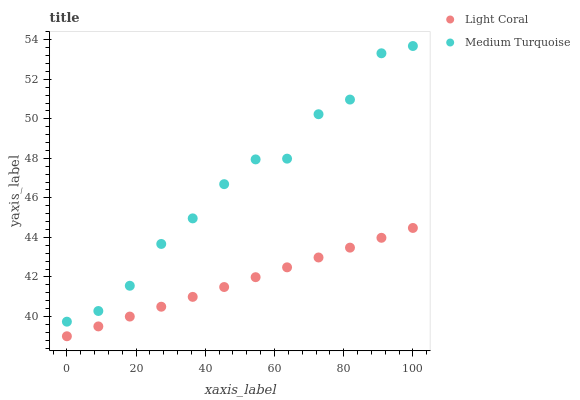Does Light Coral have the minimum area under the curve?
Answer yes or no. Yes. Does Medium Turquoise have the maximum area under the curve?
Answer yes or no. Yes. Does Medium Turquoise have the minimum area under the curve?
Answer yes or no. No. Is Light Coral the smoothest?
Answer yes or no. Yes. Is Medium Turquoise the roughest?
Answer yes or no. Yes. Is Medium Turquoise the smoothest?
Answer yes or no. No. Does Light Coral have the lowest value?
Answer yes or no. Yes. Does Medium Turquoise have the lowest value?
Answer yes or no. No. Does Medium Turquoise have the highest value?
Answer yes or no. Yes. Is Light Coral less than Medium Turquoise?
Answer yes or no. Yes. Is Medium Turquoise greater than Light Coral?
Answer yes or no. Yes. Does Light Coral intersect Medium Turquoise?
Answer yes or no. No. 